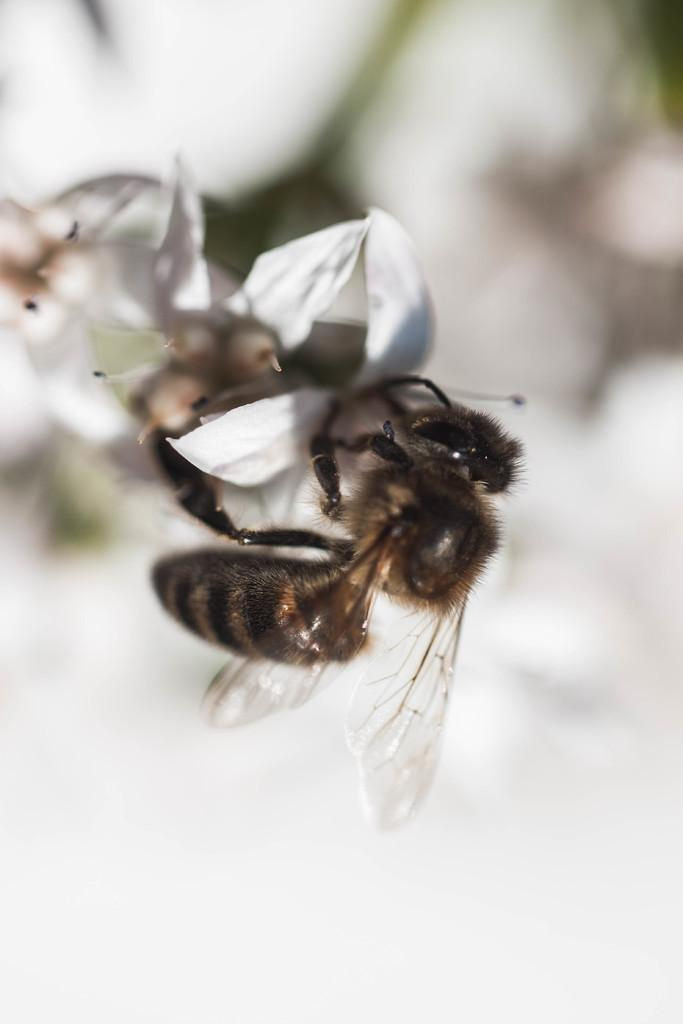What is present in the image? There is a bee in the image. Where is the bee located? The bee is on a flower. What type of beef can be seen hanging from the curtain in the image? There is no beef or curtain present in the image; it features a bee on a flower. What type of drawer is visible in the image? There is no drawer present in the image. 